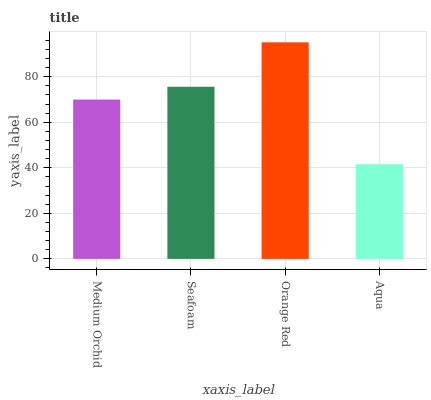Is Seafoam the minimum?
Answer yes or no. No. Is Seafoam the maximum?
Answer yes or no. No. Is Seafoam greater than Medium Orchid?
Answer yes or no. Yes. Is Medium Orchid less than Seafoam?
Answer yes or no. Yes. Is Medium Orchid greater than Seafoam?
Answer yes or no. No. Is Seafoam less than Medium Orchid?
Answer yes or no. No. Is Seafoam the high median?
Answer yes or no. Yes. Is Medium Orchid the low median?
Answer yes or no. Yes. Is Aqua the high median?
Answer yes or no. No. Is Aqua the low median?
Answer yes or no. No. 